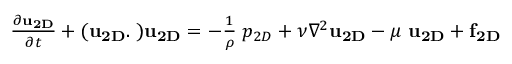Convert formula to latex. <formula><loc_0><loc_0><loc_500><loc_500>\begin{array} { r } { \frac { \partial { u } _ { 2 D } } { \partial t } + ( { u } _ { 2 D } . { \nabla } ) { u } _ { 2 D } = - \frac { 1 } { \rho } { \nabla } p _ { 2 D } + \nu \nabla ^ { 2 } { u } _ { 2 D } - \mu \ { u } _ { 2 D } + { f } _ { 2 D } } \end{array}</formula> 